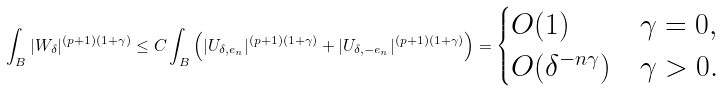<formula> <loc_0><loc_0><loc_500><loc_500>\int _ { B } | W _ { \delta } | ^ { ( p + 1 ) ( 1 + \gamma ) } \leq C \int _ { B } \left ( | U _ { \delta , e _ { n } } | ^ { ( p + 1 ) ( 1 + \gamma ) } + | U _ { \delta , - e _ { n } } | ^ { ( p + 1 ) ( 1 + \gamma ) } \right ) = \begin{cases} O ( 1 ) & \gamma = 0 , \\ O ( \delta ^ { - { n \gamma } } ) & \gamma > 0 . \end{cases}</formula> 